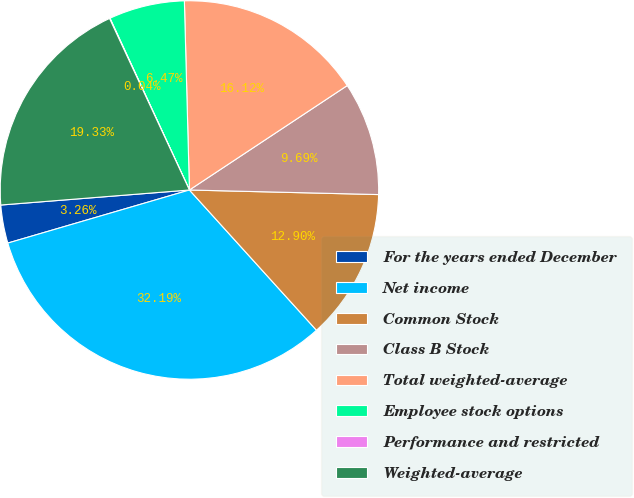Convert chart to OTSL. <chart><loc_0><loc_0><loc_500><loc_500><pie_chart><fcel>For the years ended December<fcel>Net income<fcel>Common Stock<fcel>Class B Stock<fcel>Total weighted-average<fcel>Employee stock options<fcel>Performance and restricted<fcel>Weighted-average<nl><fcel>3.26%<fcel>32.19%<fcel>12.9%<fcel>9.69%<fcel>16.12%<fcel>6.47%<fcel>0.04%<fcel>19.33%<nl></chart> 